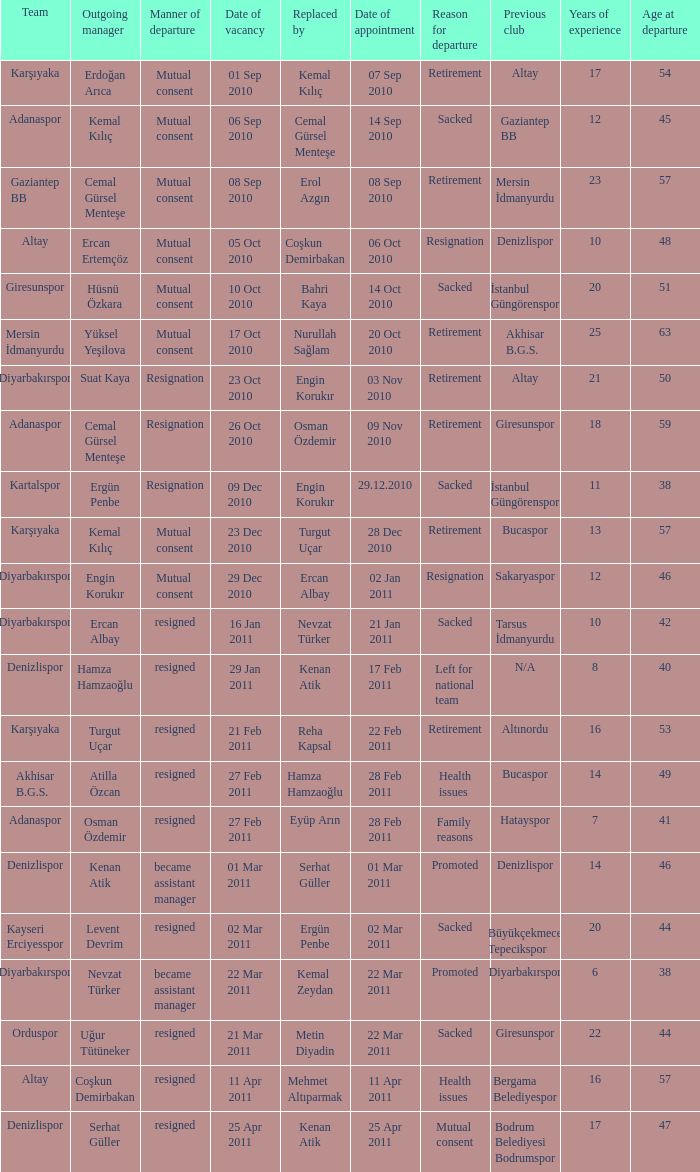Who replaced the manager of Akhisar B.G.S.? Hamza Hamzaoğlu. Write the full table. {'header': ['Team', 'Outgoing manager', 'Manner of departure', 'Date of vacancy', 'Replaced by', 'Date of appointment', 'Reason for departure', 'Previous club', 'Years of experience', 'Age at departure'], 'rows': [['Karşıyaka', 'Erdoğan Arıca', 'Mutual consent', '01 Sep 2010', 'Kemal Kılıç', '07 Sep 2010', 'Retirement', 'Altay', '17', '54'], ['Adanaspor', 'Kemal Kılıç', 'Mutual consent', '06 Sep 2010', 'Cemal Gürsel Menteşe', '14 Sep 2010', 'Sacked', 'Gaziantep BB', '12', '45'], ['Gaziantep BB', 'Cemal Gürsel Menteşe', 'Mutual consent', '08 Sep 2010', 'Erol Azgın', '08 Sep 2010', 'Retirement', 'Mersin İdmanyurdu', '23', '57'], ['Altay', 'Ercan Ertemçöz', 'Mutual consent', '05 Oct 2010', 'Coşkun Demirbakan', '06 Oct 2010', 'Resignation', 'Denizlispor', '10', '48'], ['Giresunspor', 'Hüsnü Özkara', 'Mutual consent', '10 Oct 2010', 'Bahri Kaya', '14 Oct 2010', 'Sacked', 'İstanbul Güngörenspor', '20', '51'], ['Mersin İdmanyurdu', 'Yüksel Yeşilova', 'Mutual consent', '17 Oct 2010', 'Nurullah Sağlam', '20 Oct 2010', 'Retirement', 'Akhisar B.G.S.', '25', '63'], ['Diyarbakırspor', 'Suat Kaya', 'Resignation', '23 Oct 2010', 'Engin Korukır', '03 Nov 2010', 'Retirement', 'Altay', '21', '50'], ['Adanaspor', 'Cemal Gürsel Menteşe', 'Resignation', '26 Oct 2010', 'Osman Özdemir', '09 Nov 2010', 'Retirement', 'Giresunspor', '18', '59'], ['Kartalspor', 'Ergün Penbe', 'Resignation', '09 Dec 2010', 'Engin Korukır', '29.12.2010', 'Sacked', 'İstanbul Güngörenspor', '11', '38'], ['Karşıyaka', 'Kemal Kılıç', 'Mutual consent', '23 Dec 2010', 'Turgut Uçar', '28 Dec 2010', 'Retirement', 'Bucaspor', '13', '57'], ['Diyarbakırspor', 'Engin Korukır', 'Mutual consent', '29 Dec 2010', 'Ercan Albay', '02 Jan 2011', 'Resignation', 'Sakaryaspor', '12', '46'], ['Diyarbakırspor', 'Ercan Albay', 'resigned', '16 Jan 2011', 'Nevzat Türker', '21 Jan 2011', 'Sacked', 'Tarsus İdmanyurdu', '10', '42'], ['Denizlispor', 'Hamza Hamzaoğlu', 'resigned', '29 Jan 2011', 'Kenan Atik', '17 Feb 2011', 'Left for national team', 'N/A', '8', '40'], ['Karşıyaka', 'Turgut Uçar', 'resigned', '21 Feb 2011', 'Reha Kapsal', '22 Feb 2011', 'Retirement', 'Altınordu', '16', '53'], ['Akhisar B.G.S.', 'Atilla Özcan', 'resigned', '27 Feb 2011', 'Hamza Hamzaoğlu', '28 Feb 2011', 'Health issues', 'Bucaspor', '14', '49'], ['Adanaspor', 'Osman Özdemir', 'resigned', '27 Feb 2011', 'Eyüp Arın', '28 Feb 2011', 'Family reasons', 'Hatayspor', '7', '41'], ['Denizlispor', 'Kenan Atik', 'became assistant manager', '01 Mar 2011', 'Serhat Güller', '01 Mar 2011', 'Promoted', 'Denizlispor', '14', '46'], ['Kayseri Erciyesspor', 'Levent Devrim', 'resigned', '02 Mar 2011', 'Ergün Penbe', '02 Mar 2011', 'Sacked', 'Büyükçekmece Tepecikspor', '20', '44'], ['Diyarbakırspor', 'Nevzat Türker', 'became assistant manager', '22 Mar 2011', 'Kemal Zeydan', '22 Mar 2011', 'Promoted', 'Diyarbakırspor', '6', '38'], ['Orduspor', 'Uğur Tütüneker', 'resigned', '21 Mar 2011', 'Metin Diyadin', '22 Mar 2011', 'Sacked', 'Giresunspor', '22', '44'], ['Altay', 'Coşkun Demirbakan', 'resigned', '11 Apr 2011', 'Mehmet Altıparmak', '11 Apr 2011', 'Health issues', 'Bergama Belediyespor', '16', '57'], ['Denizlispor', 'Serhat Güller', 'resigned', '25 Apr 2011', 'Kenan Atik', '25 Apr 2011', 'Mutual consent', 'Bodrum Belediyesi Bodrumspor', '17', '47']]} 